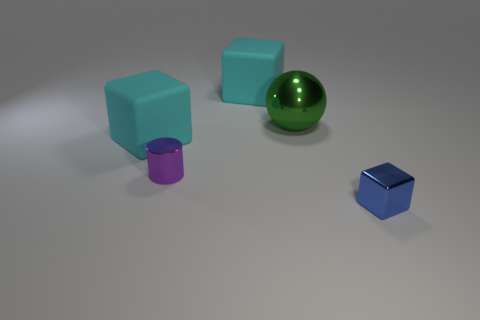What size is the cylinder on the left side of the green metal sphere?
Offer a very short reply. Small. Is the color of the metal cylinder the same as the object that is behind the sphere?
Keep it short and to the point. No. Is there a big matte object of the same color as the tiny block?
Give a very brief answer. No. Do the small purple object and the small thing that is in front of the tiny purple metallic thing have the same material?
Your response must be concise. Yes. What number of large objects are gray matte things or cyan blocks?
Ensure brevity in your answer.  2. Are there fewer large green balls than red shiny objects?
Provide a succinct answer. No. Is the size of the cyan thing that is on the left side of the purple cylinder the same as the rubber block that is behind the green thing?
Ensure brevity in your answer.  Yes. How many cyan things are either large cubes or big shiny objects?
Ensure brevity in your answer.  2. Is the number of gray cylinders greater than the number of purple shiny objects?
Make the answer very short. No. Do the big metallic sphere and the cylinder have the same color?
Provide a short and direct response. No. 